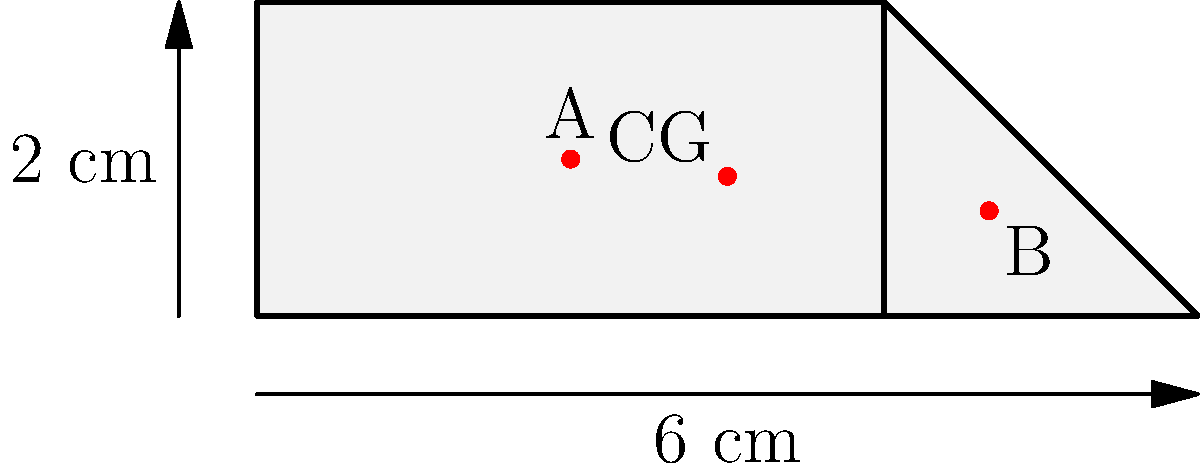A composite shape is formed by a rectangle (4 cm x 2 cm) and a right-angled triangle (base 2 cm, height 2 cm) as shown in the figure. Point A (2,1) is the center of gravity of the rectangle, and point B (4.67,0.67) is the center of gravity of the triangle. Determine the x-coordinate of the center of gravity (CG) of the entire composite shape. To find the center of gravity of the composite shape, we need to follow these steps:

1) Calculate the areas of both shapes:
   Rectangle area: $A_r = 4 \times 2 = 8$ cm²
   Triangle area: $A_t = \frac{1}{2} \times 2 \times 2 = 2$ cm²

2) Calculate the total area:
   $A_{\text{total}} = A_r + A_t = 8 + 2 = 10$ cm²

3) Use the formula for the x-coordinate of the center of gravity:
   $$x_{\text{CG}} = \frac{A_r x_A + A_t x_B}{A_{\text{total}}}$$

   Where $x_A$ and $x_B$ are the x-coordinates of points A and B respectively.

4) Substitute the values:
   $$x_{\text{CG}} = \frac{8 \times 2 + 2 \times 4.67}{10}$$

5) Calculate:
   $$x_{\text{CG}} = \frac{16 + 9.34}{10} = \frac{25.34}{10} = 2.534$$

Therefore, the x-coordinate of the center of gravity of the composite shape is 2.534 cm from the left edge of the rectangle.
Answer: 2.534 cm 